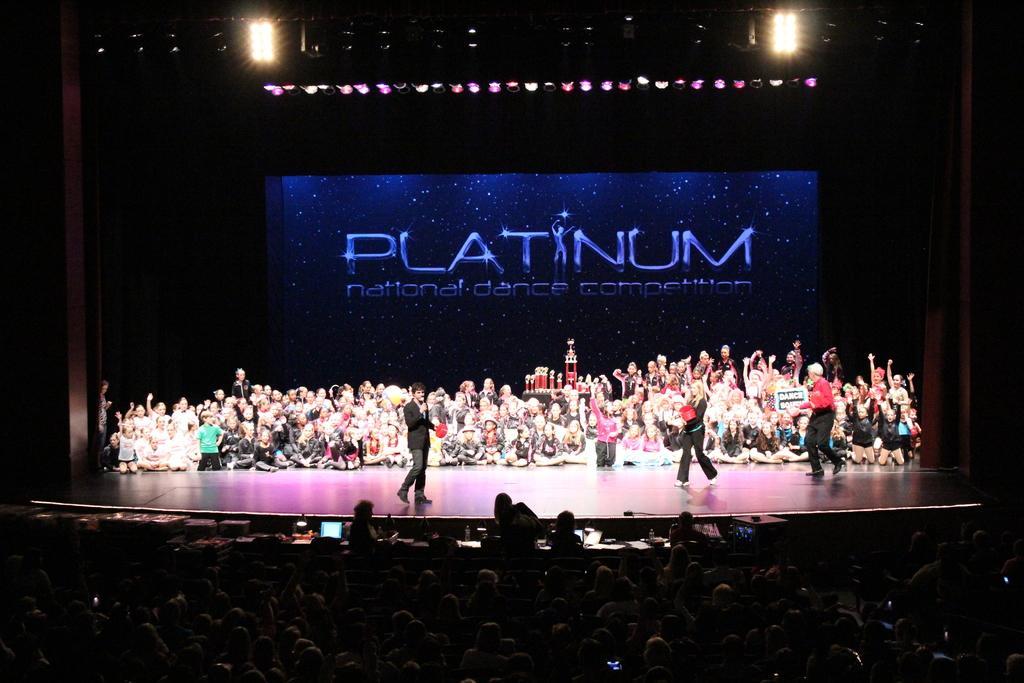Could you give a brief overview of what you see in this image? This picture shows few people seated on the dais and we see few people standing and we see audience seated and we see laptop on the table and we see led screen on the back and few lights. 